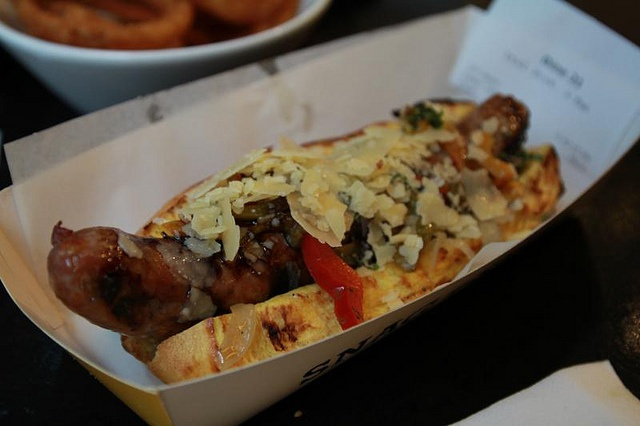Describe the objects in this image and their specific colors. I can see bowl in brown, darkgray, tan, black, and maroon tones, hot dog in brown, maroon, black, tan, and olive tones, dining table in brown, black, darkgray, and gray tones, and bowl in brown, maroon, black, gray, and darkgray tones in this image. 